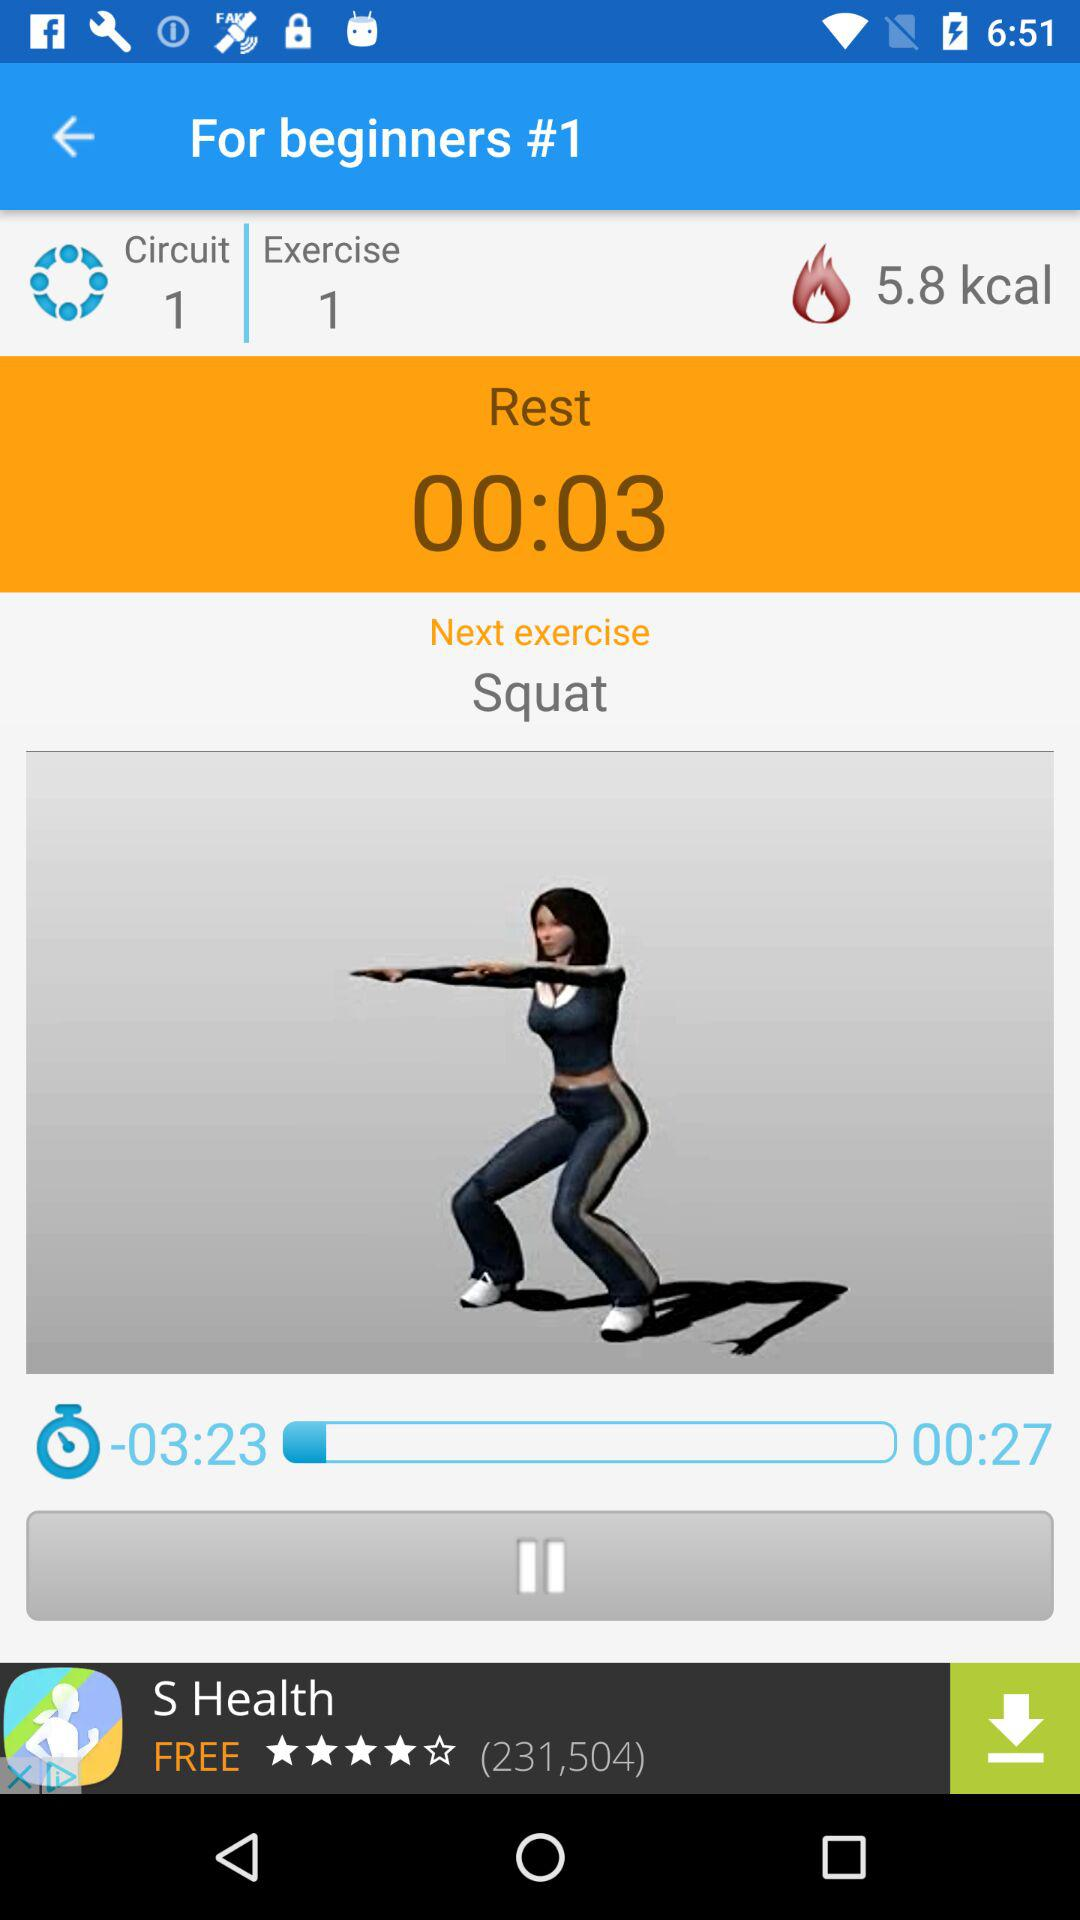How many more seconds are left in the workout than the rest?
Answer the question using a single word or phrase. 24 